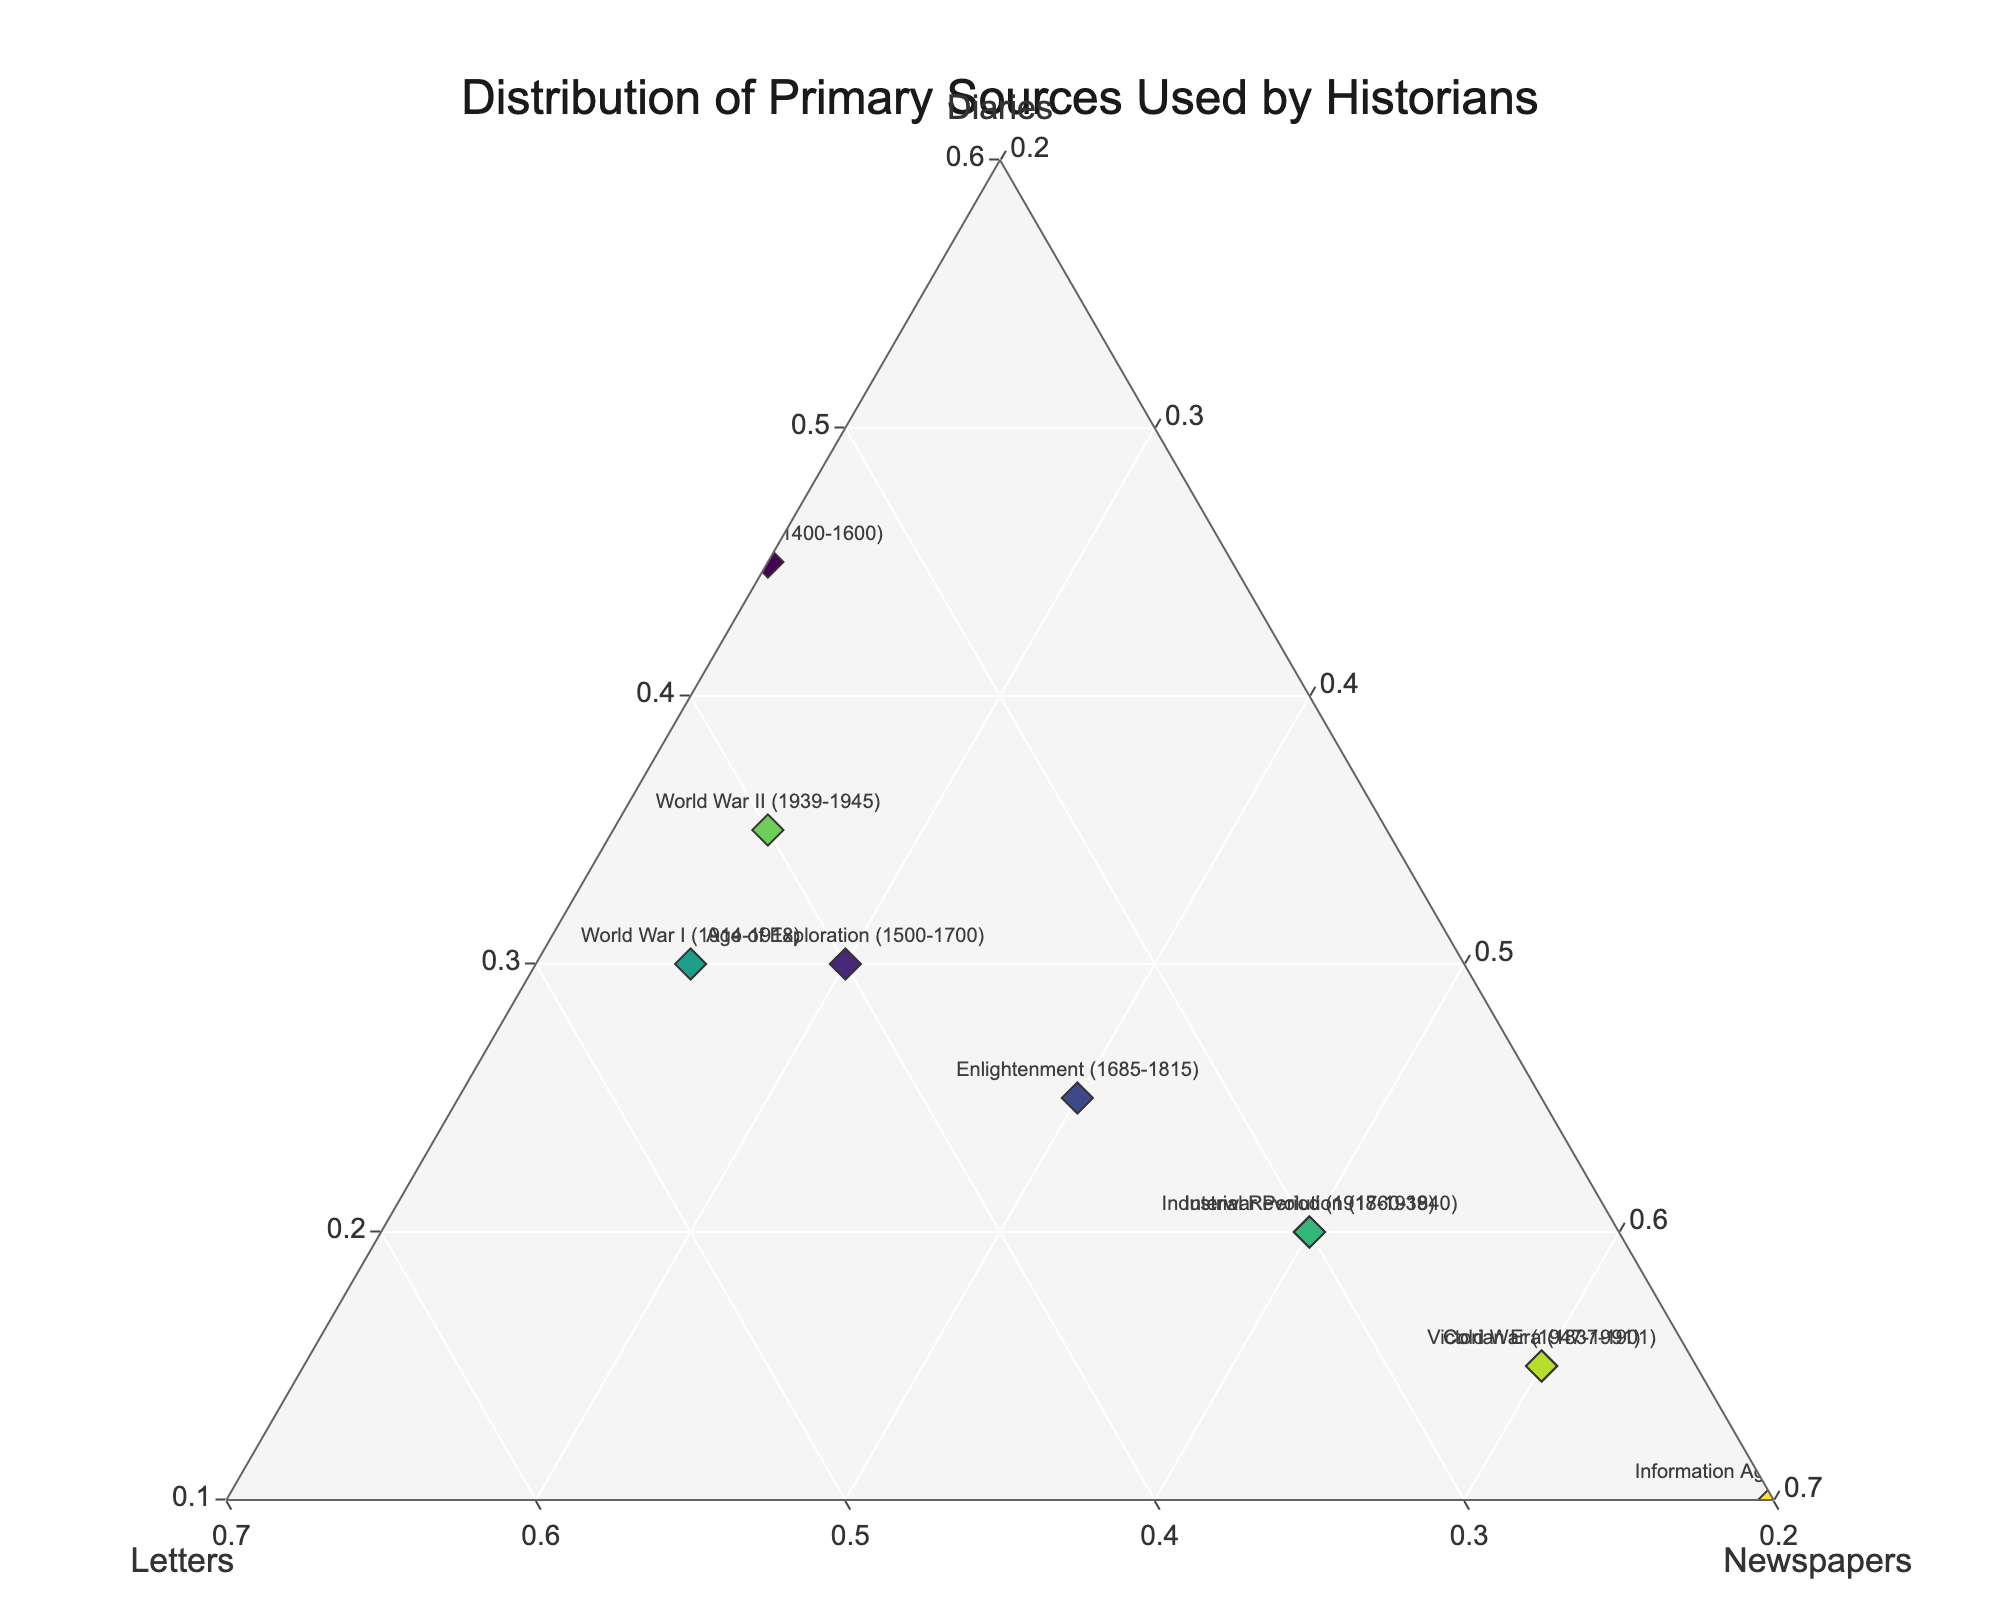What is the title of the figure? The title is located at the top center of the figure. It is written in a large, distinct font.
Answer: Distribution of Primary Sources Used by Historians How many time periods are represented in the figure? The number of time periods can be counted based on their labels.
Answer: 10 Which time period relies most heavily on newspapers as primary sources? Identify the point that is closest to the 'Newspapers' vertex. This would be the period with the highest percentage of newspapers used.
Answer: Information Age (1970-present) Which time periods have the highest and lowest proportions of diaries? Find the points closest and farthest from the 'Diaries' vertex.
Answer: Highest: Renaissance (1400-1600), Lowest: Information Age (1970-present) What is the range of proportions for letters across all time periods? Review the 'Letters' axis for the lowest and highest values used. The range is the difference between these two values.
Answer: 0.2 to 0.45 Which time period has an equal proportion of diaries and newspapers used as primary sources? Find the point where the 'Diaries' and 'Newspapers' proportions are equal.
Answer: World War II (1939-1945) During which time period is the use of letters as primary sources twice that of diaries? Search for the time period where the proportion of letters is exactly double the proportion of diaries.
Answer: World War I (1914-1918) How does the reliance on newspapers in the Victorian Era compare to the Enlightenment? Look at the figures for the Victorian Era and the Enlightenment on the 'Newspapers' axis and compare the values.
Answer: The Victorian Era has a higher reliance on newspapers (0.60 vs 0.40) Which time period shows a balanced use of diaries, letters, and newspapers? Look for a point near the center of the ternary plot, indicating balanced use.
Answer: Age of Exploration (1500-1700) 